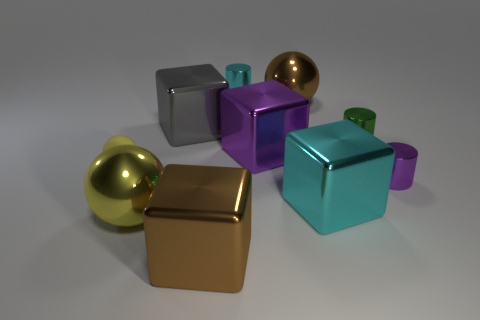There is a shiny object that is the same color as the tiny rubber ball; what shape is it?
Ensure brevity in your answer.  Sphere. There is a object that is the same color as the rubber sphere; what is its size?
Make the answer very short. Large. The matte object that is the same shape as the yellow metallic thing is what color?
Ensure brevity in your answer.  Yellow. How many metallic things have the same color as the rubber thing?
Provide a succinct answer. 1. Is the number of yellow spheres that are behind the small green cylinder greater than the number of brown spheres?
Keep it short and to the point. No. There is a big metal sphere in front of the small metal cylinder that is in front of the tiny rubber thing; what is its color?
Provide a succinct answer. Yellow. What number of things are either objects behind the large yellow thing or big brown things on the left side of the purple metal cube?
Offer a very short reply. 9. How many other large blocks have the same material as the big purple cube?
Your response must be concise. 3. Are there more large spheres than large brown rubber cylinders?
Make the answer very short. Yes. There is a cube behind the large purple metallic block; how many large shiny spheres are in front of it?
Make the answer very short. 1. 